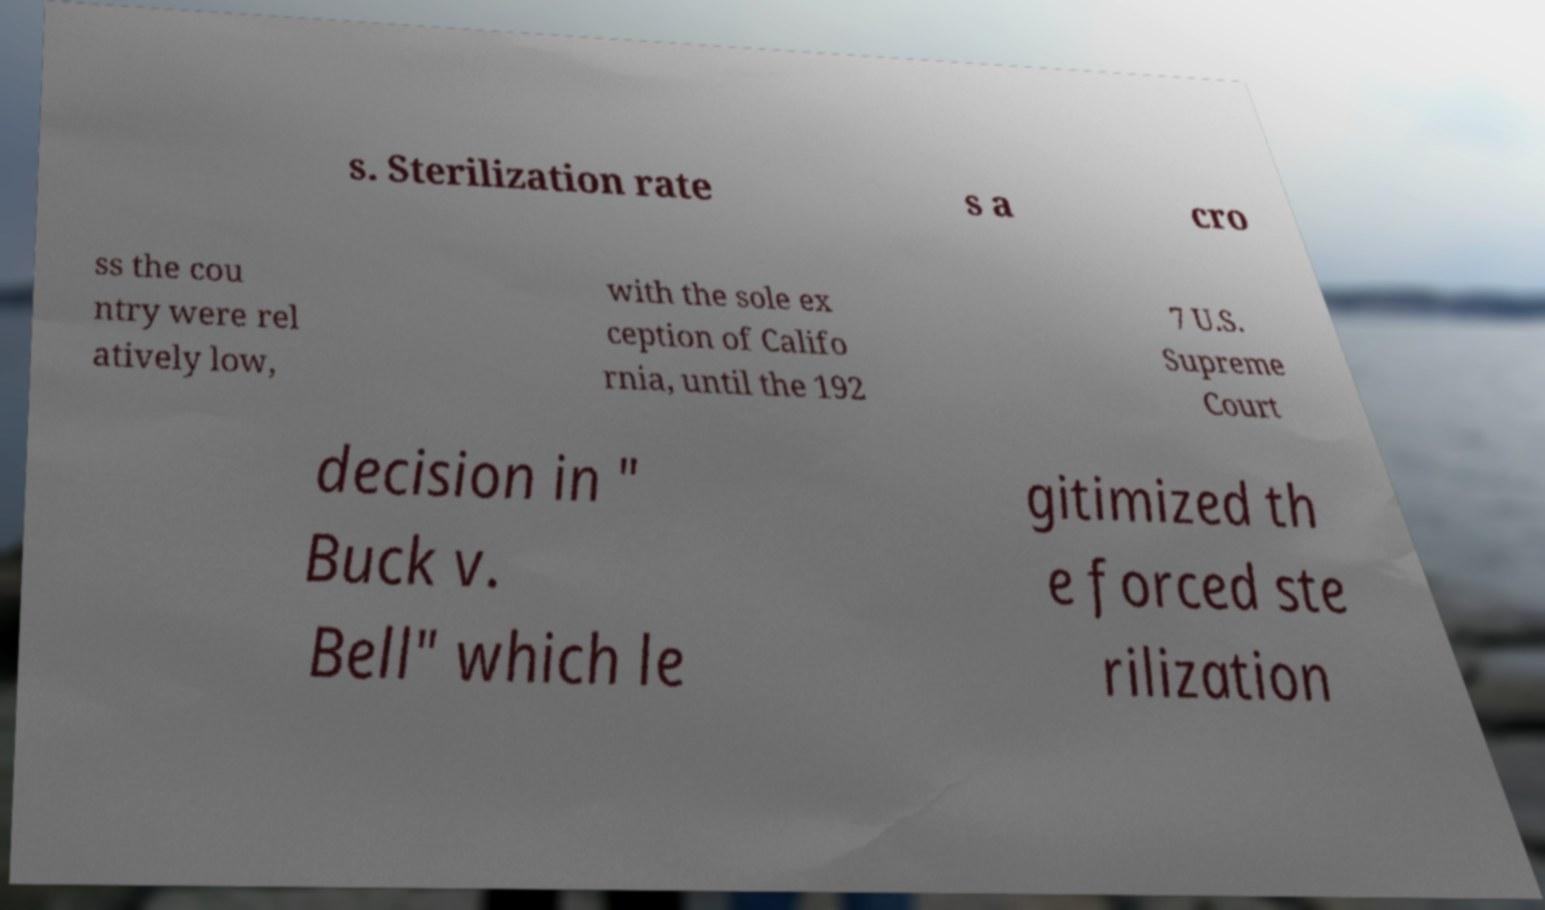For documentation purposes, I need the text within this image transcribed. Could you provide that? s. Sterilization rate s a cro ss the cou ntry were rel atively low, with the sole ex ception of Califo rnia, until the 192 7 U.S. Supreme Court decision in " Buck v. Bell" which le gitimized th e forced ste rilization 